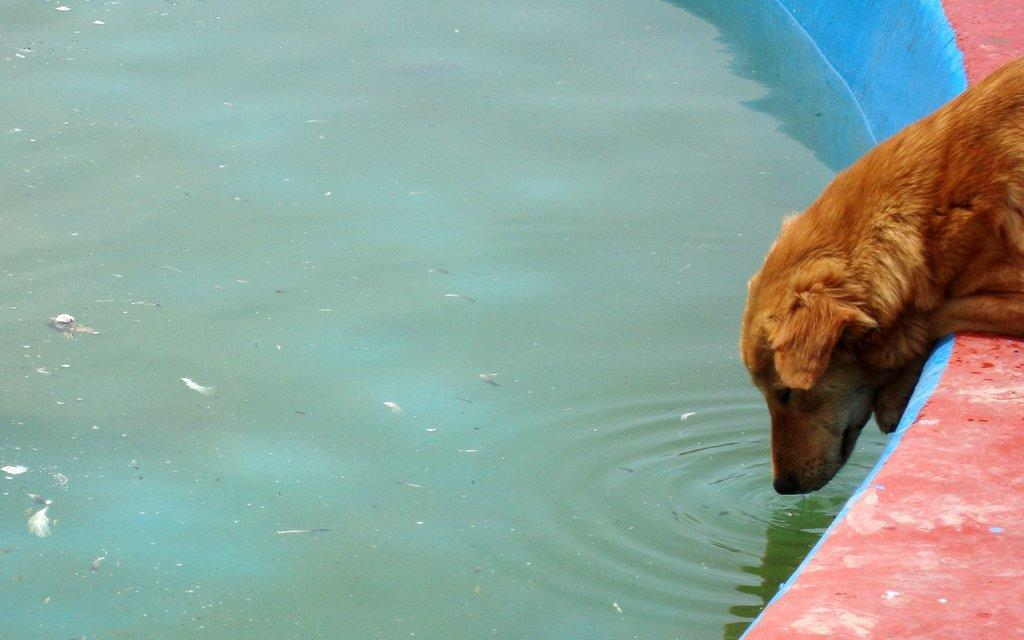What type of animal is in the image? There is a dog in the image. What is the dog doing in the image? The dog is sitting in the image. Where is the dog located in relation to the water? The dog is near the water in the image. What type of play equipment can be seen near the dog in the image? There is no play equipment visible near the dog in the image. 